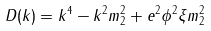Convert formula to latex. <formula><loc_0><loc_0><loc_500><loc_500>D ( k ) = k ^ { 4 } - k ^ { 2 } m ^ { 2 } _ { 2 } + e ^ { 2 } \phi ^ { 2 } \xi m _ { 2 } ^ { 2 }</formula> 